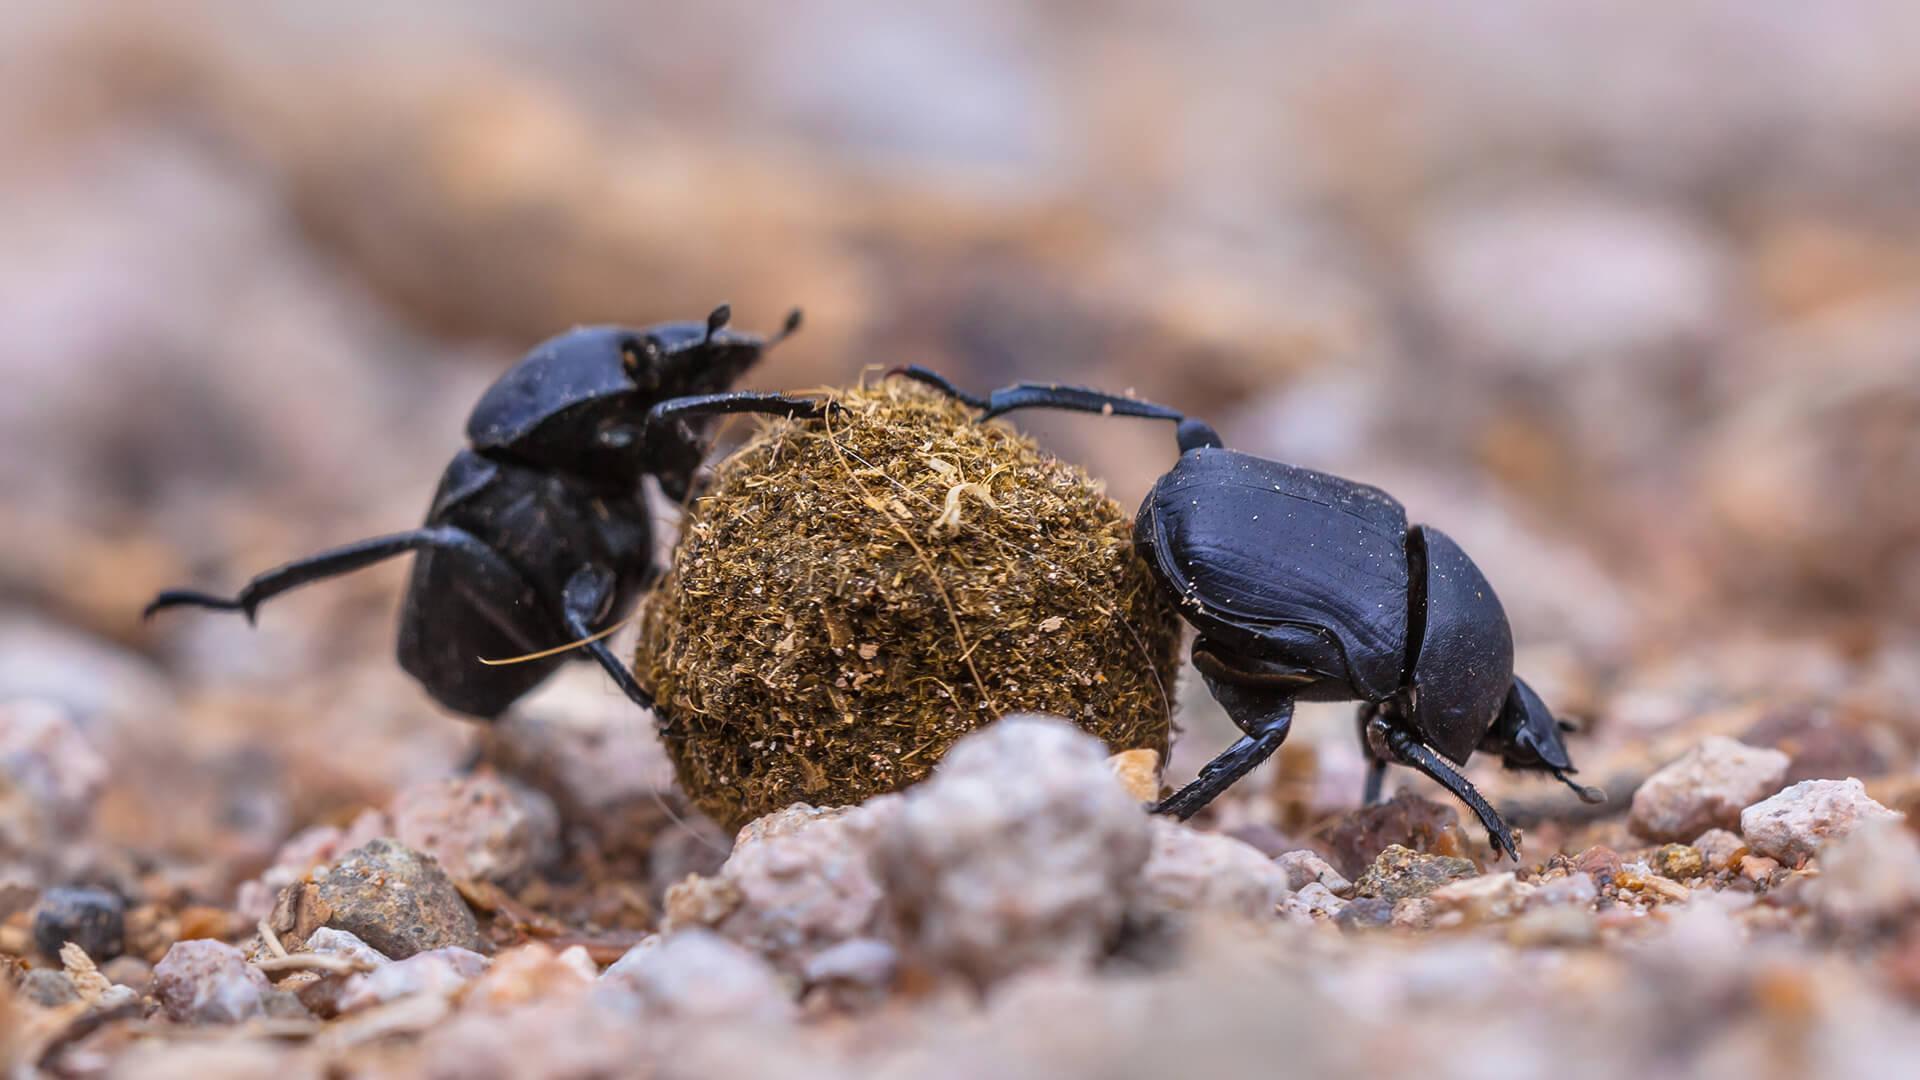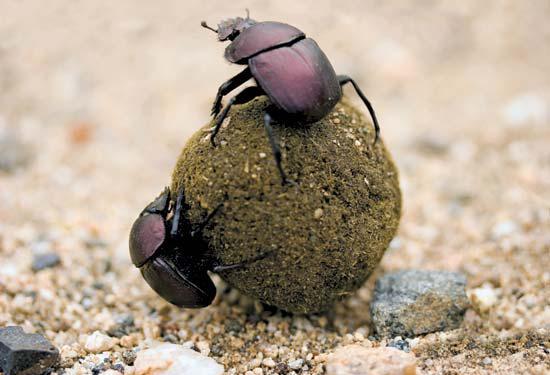The first image is the image on the left, the second image is the image on the right. For the images displayed, is the sentence "Each image has at least 2 dung beetles with a ball of dung." factually correct? Answer yes or no. Yes. The first image is the image on the left, the second image is the image on the right. For the images shown, is this caption "There are two dung beetles." true? Answer yes or no. No. 